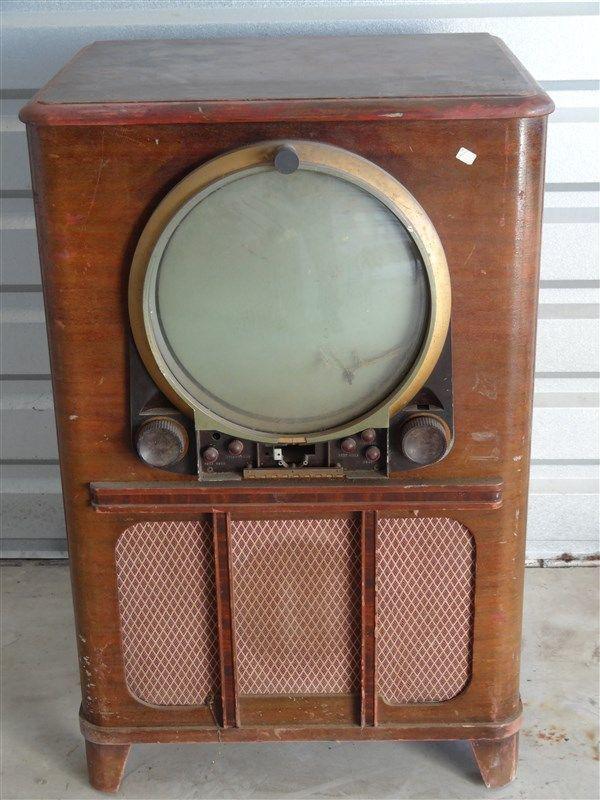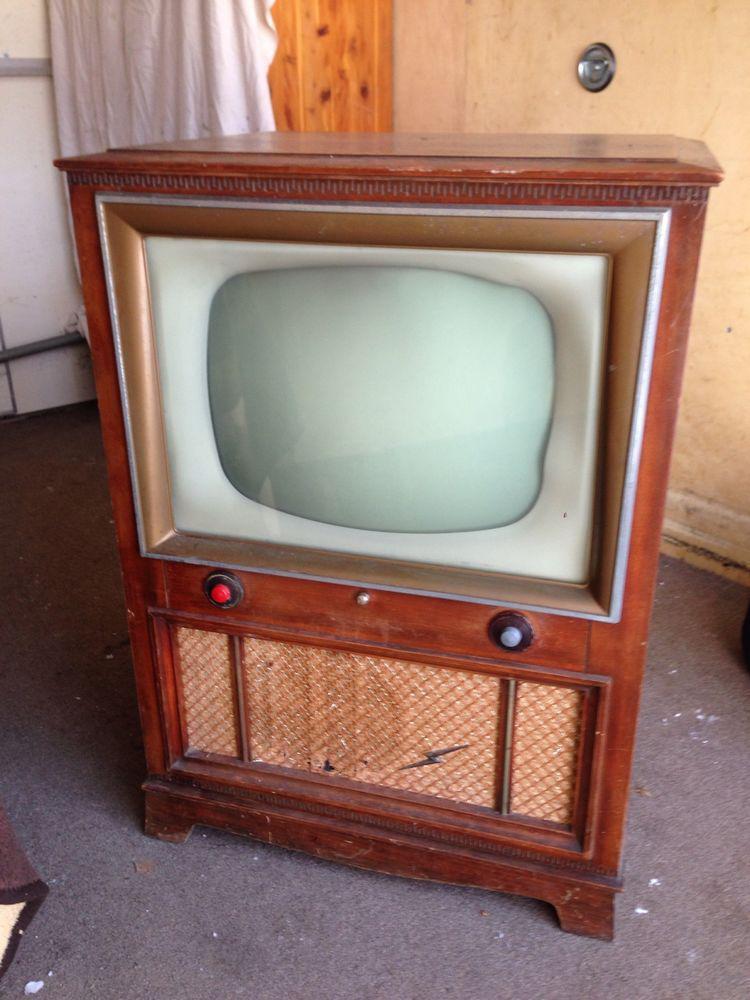The first image is the image on the left, the second image is the image on the right. For the images displayed, is the sentence "Each of two televisions is contained in the upper section of a wooden cabinet with a speaker area under the television, and two visible control knobs." factually correct? Answer yes or no. Yes. 